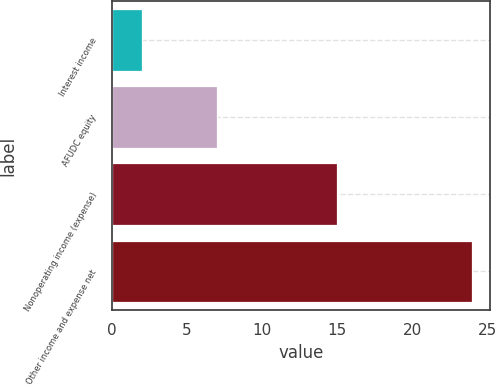Convert chart. <chart><loc_0><loc_0><loc_500><loc_500><bar_chart><fcel>Interest income<fcel>AFUDC equity<fcel>Nonoperating income (expense)<fcel>Other income and expense net<nl><fcel>2<fcel>7<fcel>15<fcel>24<nl></chart> 